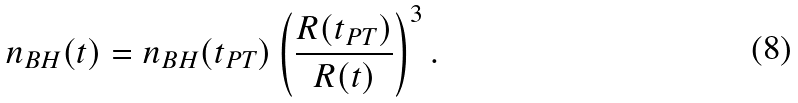<formula> <loc_0><loc_0><loc_500><loc_500>n _ { B H } ( t ) = n _ { B H } ( t _ { P T } ) \left ( \frac { R ( t _ { P T } ) } { R ( t ) } \right ) ^ { 3 } .</formula> 